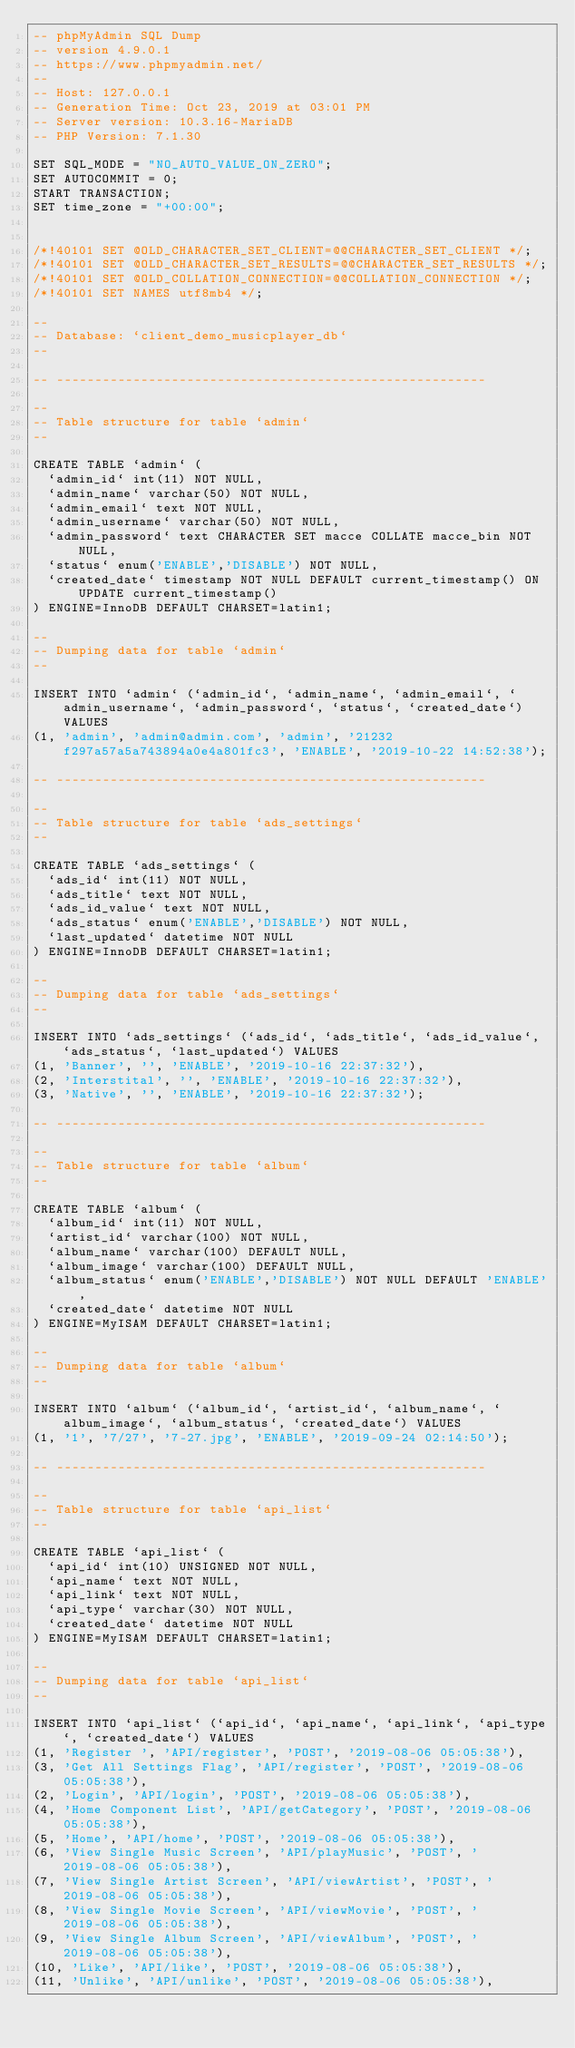<code> <loc_0><loc_0><loc_500><loc_500><_SQL_>-- phpMyAdmin SQL Dump
-- version 4.9.0.1
-- https://www.phpmyadmin.net/
--
-- Host: 127.0.0.1
-- Generation Time: Oct 23, 2019 at 03:01 PM
-- Server version: 10.3.16-MariaDB
-- PHP Version: 7.1.30

SET SQL_MODE = "NO_AUTO_VALUE_ON_ZERO";
SET AUTOCOMMIT = 0;
START TRANSACTION;
SET time_zone = "+00:00";


/*!40101 SET @OLD_CHARACTER_SET_CLIENT=@@CHARACTER_SET_CLIENT */;
/*!40101 SET @OLD_CHARACTER_SET_RESULTS=@@CHARACTER_SET_RESULTS */;
/*!40101 SET @OLD_COLLATION_CONNECTION=@@COLLATION_CONNECTION */;
/*!40101 SET NAMES utf8mb4 */;

--
-- Database: `client_demo_musicplayer_db`
--

-- --------------------------------------------------------

--
-- Table structure for table `admin`
--

CREATE TABLE `admin` (
  `admin_id` int(11) NOT NULL,
  `admin_name` varchar(50) NOT NULL,
  `admin_email` text NOT NULL,
  `admin_username` varchar(50) NOT NULL,
  `admin_password` text CHARACTER SET macce COLLATE macce_bin NOT NULL,
  `status` enum('ENABLE','DISABLE') NOT NULL,
  `created_date` timestamp NOT NULL DEFAULT current_timestamp() ON UPDATE current_timestamp()
) ENGINE=InnoDB DEFAULT CHARSET=latin1;

--
-- Dumping data for table `admin`
--

INSERT INTO `admin` (`admin_id`, `admin_name`, `admin_email`, `admin_username`, `admin_password`, `status`, `created_date`) VALUES
(1, 'admin', 'admin@admin.com', 'admin', '21232f297a57a5a743894a0e4a801fc3', 'ENABLE', '2019-10-22 14:52:38');

-- --------------------------------------------------------

--
-- Table structure for table `ads_settings`
--

CREATE TABLE `ads_settings` (
  `ads_id` int(11) NOT NULL,
  `ads_title` text NOT NULL,
  `ads_id_value` text NOT NULL,
  `ads_status` enum('ENABLE','DISABLE') NOT NULL,
  `last_updated` datetime NOT NULL
) ENGINE=InnoDB DEFAULT CHARSET=latin1;

--
-- Dumping data for table `ads_settings`
--

INSERT INTO `ads_settings` (`ads_id`, `ads_title`, `ads_id_value`, `ads_status`, `last_updated`) VALUES
(1, 'Banner', '', 'ENABLE', '2019-10-16 22:37:32'),
(2, 'Interstital', '', 'ENABLE', '2019-10-16 22:37:32'),
(3, 'Native', '', 'ENABLE', '2019-10-16 22:37:32');

-- --------------------------------------------------------

--
-- Table structure for table `album`
--

CREATE TABLE `album` (
  `album_id` int(11) NOT NULL,
  `artist_id` varchar(100) NOT NULL,
  `album_name` varchar(100) DEFAULT NULL,
  `album_image` varchar(100) DEFAULT NULL,
  `album_status` enum('ENABLE','DISABLE') NOT NULL DEFAULT 'ENABLE',
  `created_date` datetime NOT NULL
) ENGINE=MyISAM DEFAULT CHARSET=latin1;

--
-- Dumping data for table `album`
--

INSERT INTO `album` (`album_id`, `artist_id`, `album_name`, `album_image`, `album_status`, `created_date`) VALUES
(1, '1', '7/27', '7-27.jpg', 'ENABLE', '2019-09-24 02:14:50');

-- --------------------------------------------------------

--
-- Table structure for table `api_list`
--

CREATE TABLE `api_list` (
  `api_id` int(10) UNSIGNED NOT NULL,
  `api_name` text NOT NULL,
  `api_link` text NOT NULL,
  `api_type` varchar(30) NOT NULL,
  `created_date` datetime NOT NULL
) ENGINE=MyISAM DEFAULT CHARSET=latin1;

--
-- Dumping data for table `api_list`
--

INSERT INTO `api_list` (`api_id`, `api_name`, `api_link`, `api_type`, `created_date`) VALUES
(1, 'Register ', 'API/register', 'POST', '2019-08-06 05:05:38'),
(3, 'Get All Settings Flag', 'API/register', 'POST', '2019-08-06 05:05:38'),
(2, 'Login', 'API/login', 'POST', '2019-08-06 05:05:38'),
(4, 'Home Component List', 'API/getCategory', 'POST', '2019-08-06 05:05:38'),
(5, 'Home', 'API/home', 'POST', '2019-08-06 05:05:38'),
(6, 'View Single Music Screen', 'API/playMusic', 'POST', '2019-08-06 05:05:38'),
(7, 'View Single Artist Screen', 'API/viewArtist', 'POST', '2019-08-06 05:05:38'),
(8, 'View Single Movie Screen', 'API/viewMovie', 'POST', '2019-08-06 05:05:38'),
(9, 'View Single Album Screen', 'API/viewAlbum', 'POST', '2019-08-06 05:05:38'),
(10, 'Like', 'API/like', 'POST', '2019-08-06 05:05:38'),
(11, 'Unlike', 'API/unlike', 'POST', '2019-08-06 05:05:38'),</code> 